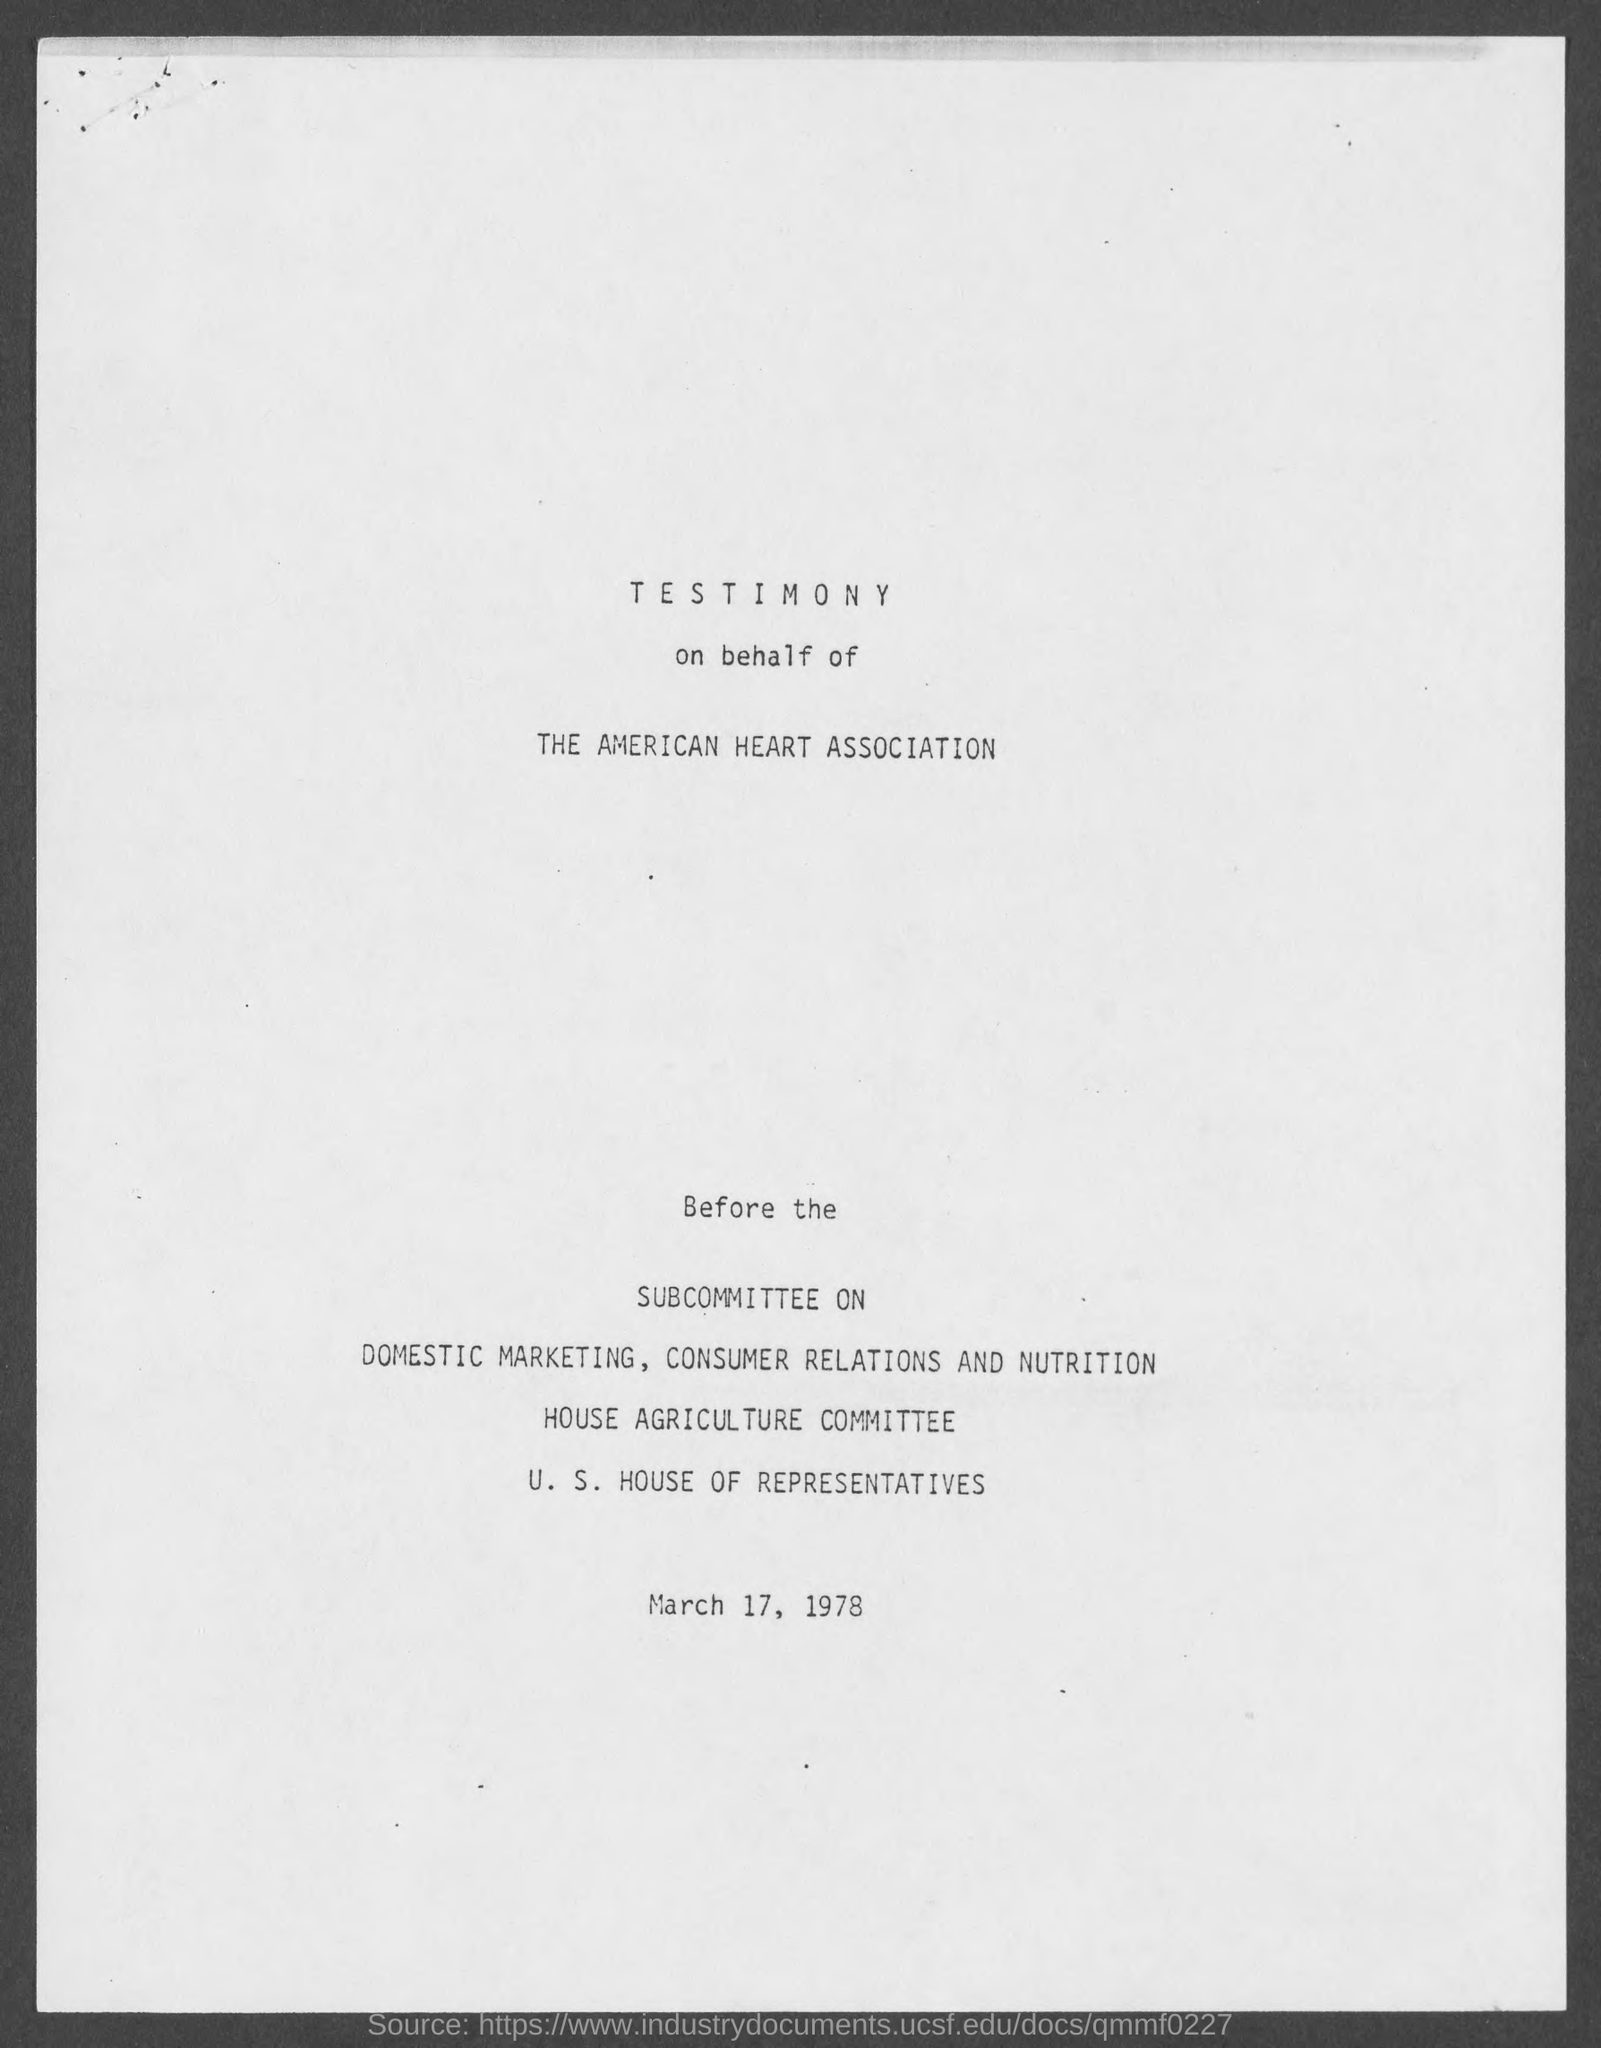On whose behalf is the testimony given?
Give a very brief answer. The American Heart Association. 